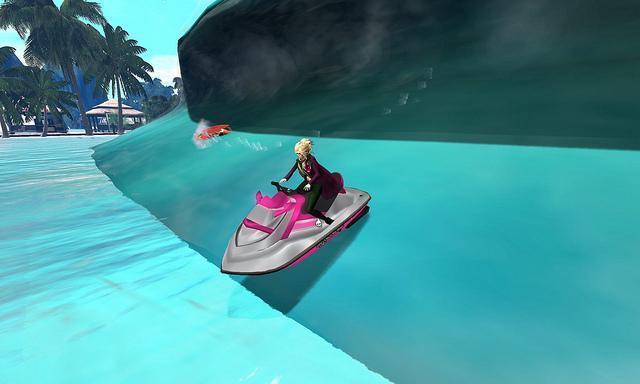How many sheep are grazing on the grass?
Give a very brief answer. 0. 